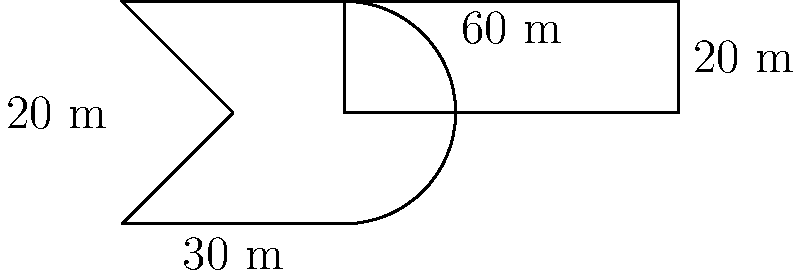Your metal band is planning a massive concert, and you've designed an electric guitar-shaped stage. The body of the guitar stage is 30 meters wide and 20 meters tall, while the neck extends 60 meters from the body and is 20 meters wide. What is the perimeter of this epic stage in meters? Let's break this down step-by-step:

1) The stage consists of two parts: the body (guitar shape) and the neck (rectangle).

2) For the body:
   - Width: 30 m
   - Height: 20 m
   - Perimeter of body ≈ 2(30 + 20) = 100 m (approximated as a rectangle)

3) For the neck:
   - Length: 60 m
   - Width: 20 m
   - We only need to add three sides of the neck (the fourth is connected to the body)
   - Perimeter contribution of neck = 60 + 20 + 60 = 140 m

4) Total perimeter:
   $$ \text{Total Perimeter} = \text{Body Perimeter} + \text{Neck Contribution} $$
   $$ \text{Total Perimeter} = 100 + 140 = 240 \text{ m} $$

Therefore, the perimeter of the electric guitar-shaped stage is approximately 240 meters.
Answer: 240 m 